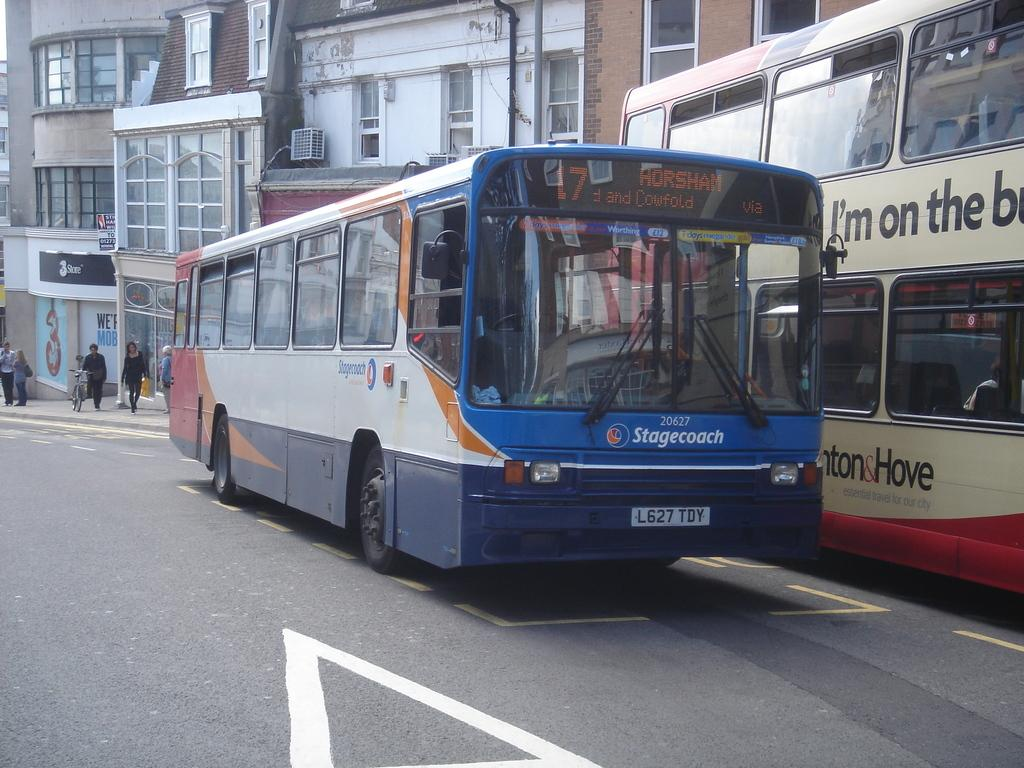<image>
Create a compact narrative representing the image presented. A blue and white city bus with Horsham written on it. 